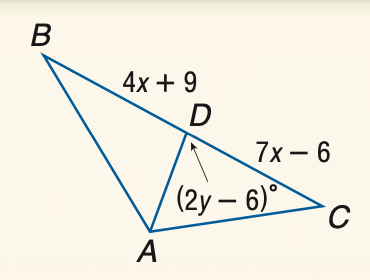Question: Find y if A D is an altitude of \triangle A B C.
Choices:
A. 42
B. 44
C. 46
D. 48
Answer with the letter. Answer: D Question: Find x if A D is a median of \triangle A B C.
Choices:
A. 3
B. 5
C. 10
D. 15
Answer with the letter. Answer: B 